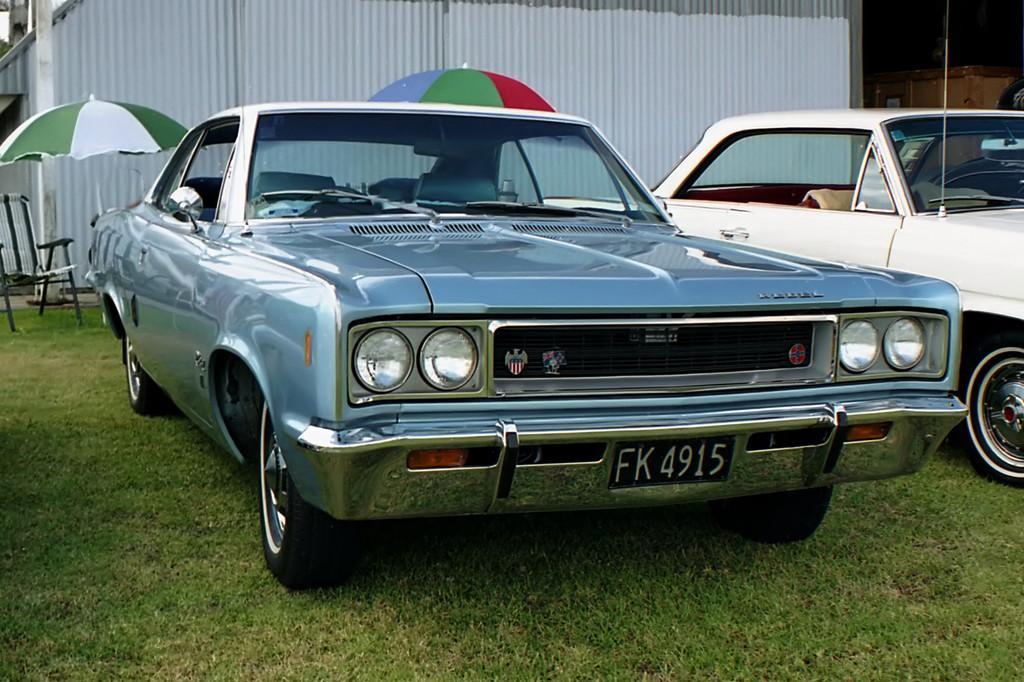In one or two sentences, can you explain what this image depicts? We can see cars on the grass. In the background we can see chair,umbrellas,wall and pole. 